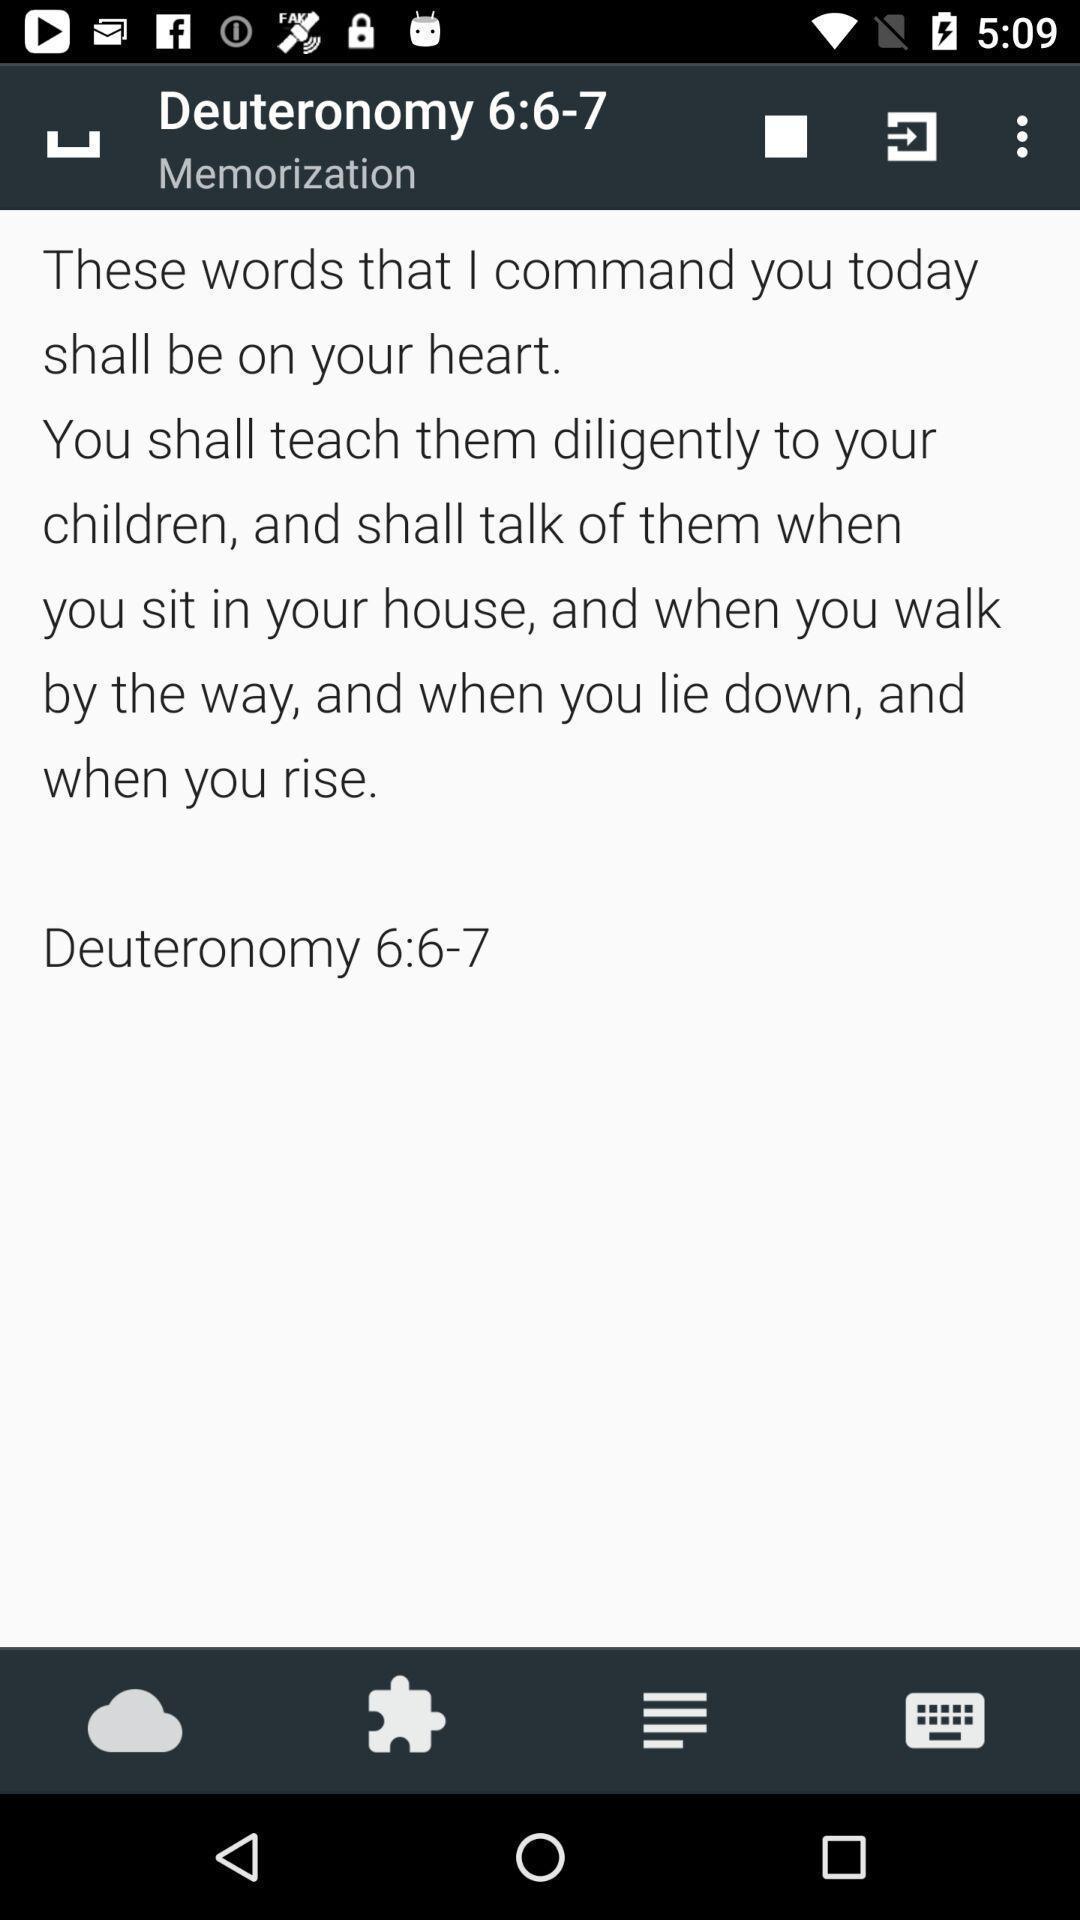Describe the visual elements of this screenshot. Page of memorization in the app. 